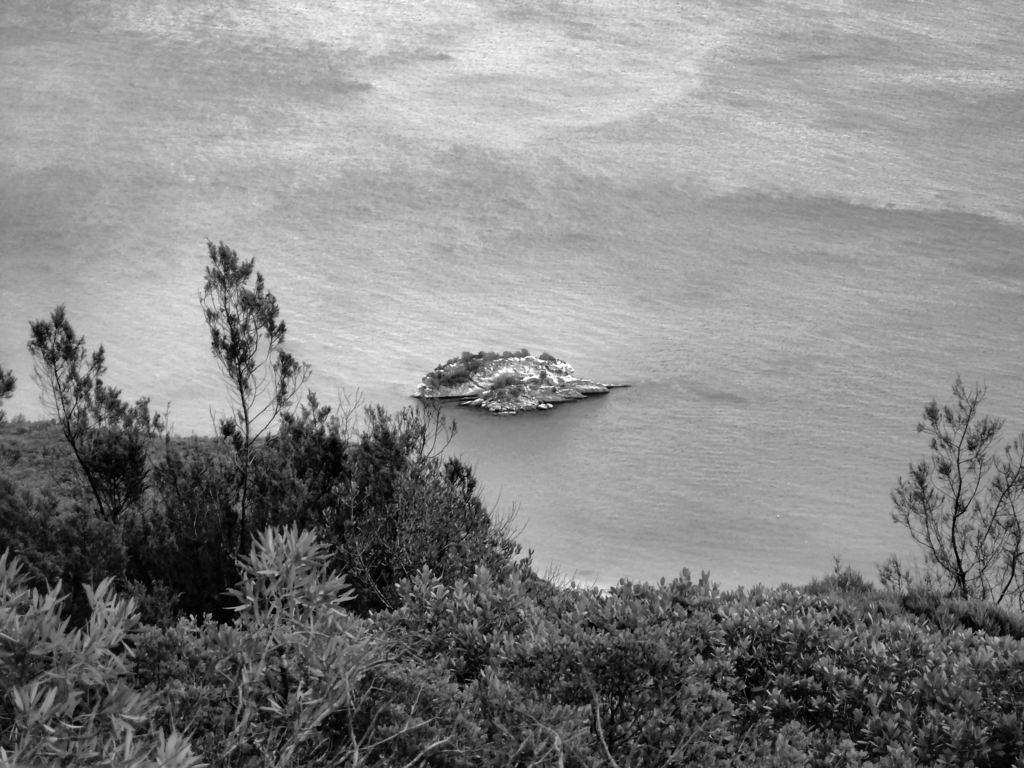Could you give a brief overview of what you see in this image? In this picture, we can see the ground with plants, trees, and we can see water and some object in the water. 